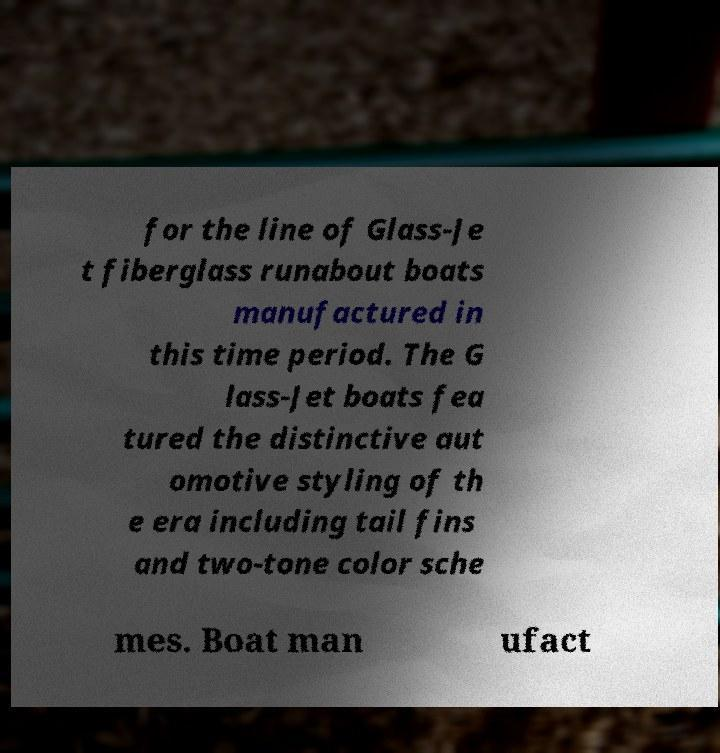For documentation purposes, I need the text within this image transcribed. Could you provide that? for the line of Glass-Je t fiberglass runabout boats manufactured in this time period. The G lass-Jet boats fea tured the distinctive aut omotive styling of th e era including tail fins and two-tone color sche mes. Boat man ufact 